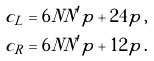<formula> <loc_0><loc_0><loc_500><loc_500>c _ { L } & = 6 N N ^ { \prime } p + 2 4 p \, , \\ c _ { R } & = 6 N N ^ { \prime } p + 1 2 p \, .</formula> 